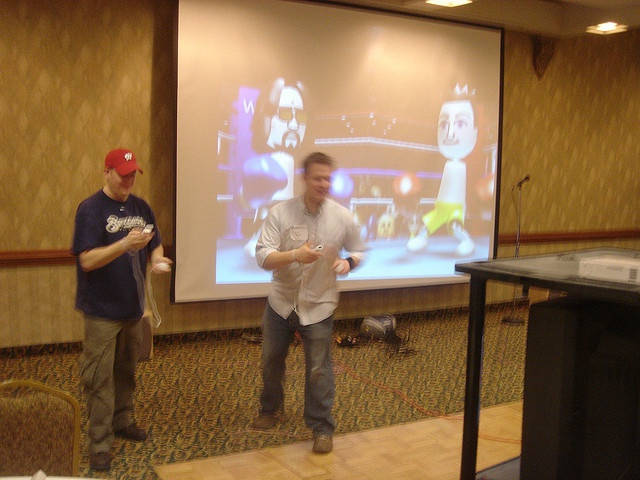Describe the objects in this image and their specific colors. I can see tv in maroon, tan, and lavender tones, tv in maroon, black, and brown tones, people in maroon, gray, black, and tan tones, people in maroon, black, and brown tones, and chair in maroon, olive, and black tones in this image. 